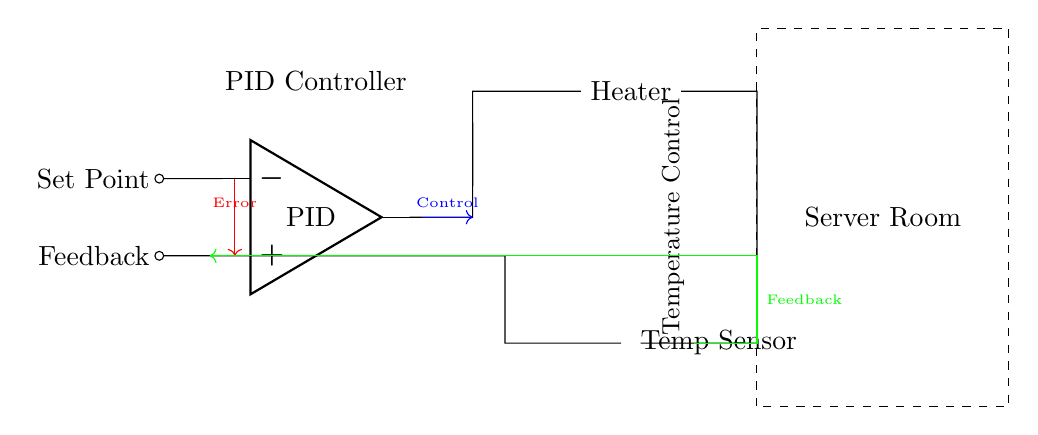What is the primary function of the PID controller in this circuit? The PID controller regulates temperature by comparing the set point with the feedback from the temperature sensor, adjusting the control signal sent to the heating element based on the error signal.
Answer: Temperature regulation What type of sensor is used in this circuit? The circuit includes a thermistor as the temperature sensor, which is identified in the diagram.
Answer: Thermistor How does the feedback loop operate in this circuit? The feedback loop involves the output of the temperature sensor being sent back to the PID controller, where it is compared to the set point to determine the necessary adjustments to the heater control signal, creating a closed loop.
Answer: Closed loop What is the role of the heating element? The heating element receives the control signal from the PID controller to adjust the temperature in the server room based on the feedback it receives.
Answer: Heat source How is the error signal indicated in the diagram? The error signal is represented by a red arrow pointing from the set point to the PID controller, indicating the difference between the desired temperature and the actual temperature.
Answer: Red arrow What type of connection is represented by the dashed rectangle surrounding the components? The dashed rectangle indicates the physical boundaries of the server room within which the temperature control system operates.
Answer: Server room What direction does the control signal flow from the PID controller? The control signal flows out of the PID controller towards the heating element, indicating the action to take based on the current temperature versus the desired set point.
Answer: To the heater 